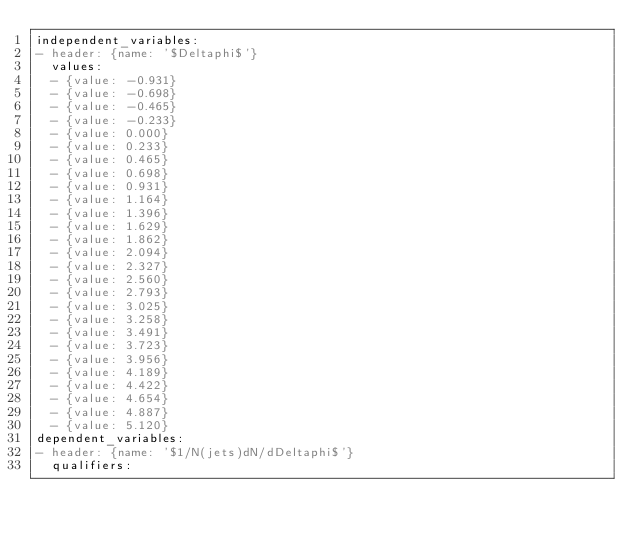Convert code to text. <code><loc_0><loc_0><loc_500><loc_500><_YAML_>independent_variables:
- header: {name: '$Deltaphi$'}
  values:
  - {value: -0.931}
  - {value: -0.698}
  - {value: -0.465}
  - {value: -0.233}
  - {value: 0.000}
  - {value: 0.233}
  - {value: 0.465}
  - {value: 0.698}
  - {value: 0.931}
  - {value: 1.164}
  - {value: 1.396}
  - {value: 1.629}
  - {value: 1.862}
  - {value: 2.094}
  - {value: 2.327}
  - {value: 2.560}
  - {value: 2.793}
  - {value: 3.025}
  - {value: 3.258}
  - {value: 3.491}
  - {value: 3.723}
  - {value: 3.956}
  - {value: 4.189}
  - {value: 4.422}
  - {value: 4.654}
  - {value: 4.887}
  - {value: 5.120}
dependent_variables:
- header: {name: '$1/N(jets)dN/dDeltaphi$'}
  qualifiers:</code> 